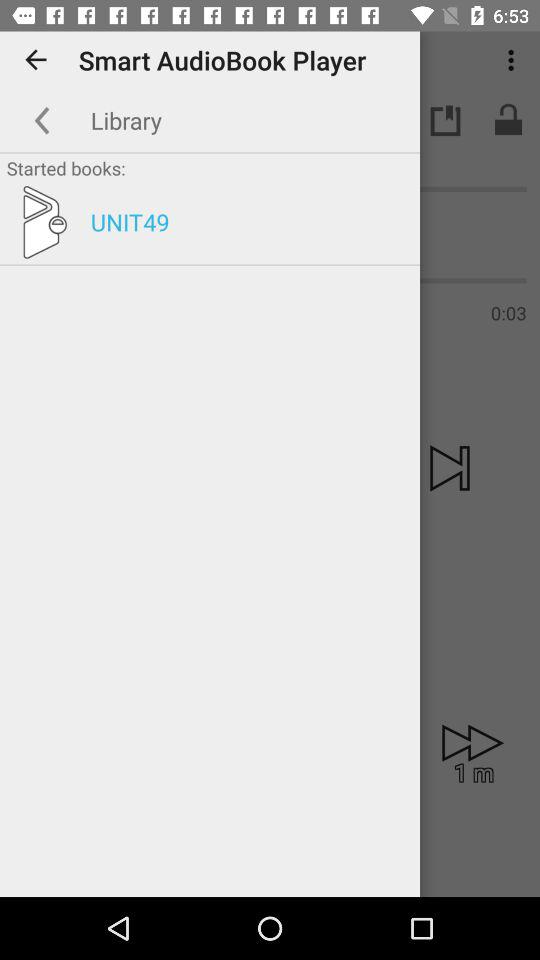What is the folder name in "Started books"? The folder name is "UNIT49". 